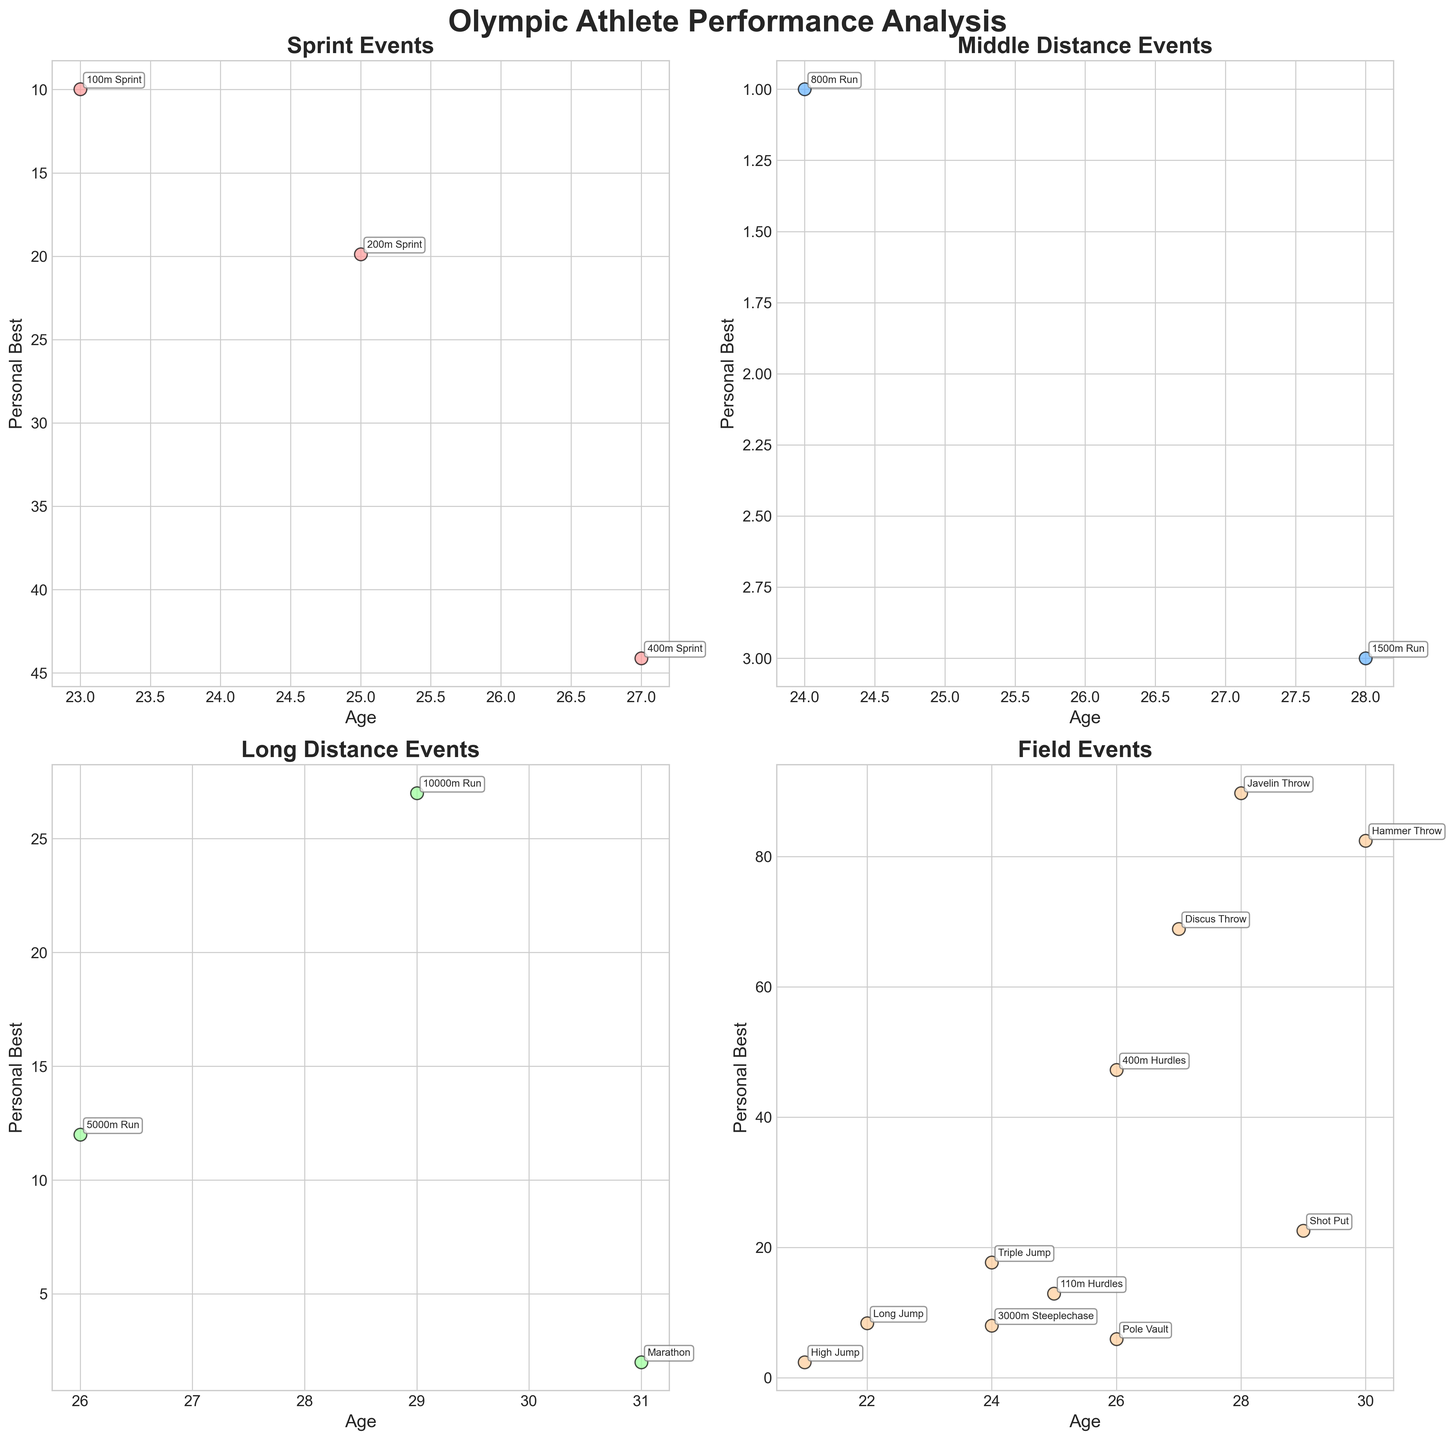How many subplots are there in the figure? There are four subplots in the figure as described in the code, each one representing a different category of athletic events (Sprint, Middle Distance, Long Distance, Field).
Answer: Four What does the x-axis represent in the subplots? The x-axis represents the age of the athletes. This is consistent across all four subplots as indicated in the code.
Answer: Age Which event has the highest average age among the sprint events? The sprint events include '100m Sprint', '200m Sprint', and '400m Sprint'. The ages are 23, 25, and 27 respectively. The average age is (23 + 25 + 27) / 3 = 25.
Answer: 400m Sprint Is there a noticeable age trend in the Field events based on the scatter plot? By observing the Field events subplot, we see a range of ages from 21 to 30. There isn’t a clear upward or downward trend visibly apparent in these age ranges.
Answer: No clear trend Among the long distance events, which event has the oldest athlete? The long distance events include the '5000m Run', '10000m Run', and 'Marathon'. The ages are 26, 29, and 31 respectively. Therefore, the Marathon has the oldest athlete at age 31.
Answer: Marathon Which subplot has events where the personal best times are inverted on the y-axis? The 'Sprint' and 'Middle Distance' subplots have the y-axis inverted for personal best times, making lower times appear higher on the graph for readability.
Answer: Sprint and Middle Distance How do personal best records compare between the '800m Run' and '1500m Run'? Looking at the 'Middle Distance' subplot, the '800m Run' personal best is 1:43.55, and the '1500m Run' is 3:29.81. Therefore, the '800m Run' has a shorter time.
Answer: Personal best for '800m Run' is shorter In the field events, which athlete has the best record in terms of distance? The events in the Field category are Long Jump, Triple Jump, Javelin Throw, Shot Put, Discus Throw, Hammer Throw, and Pole Vault. Among these, the Hammer Throw has the greatest record distance with a measure of 82.45.
Answer: Hammer Throw What can be inferred about the athletes' ages in relation to their performance in the sprint events? From the Sprint subplot, we see ages ranging from 23 to 27 and considering the inverted y-axis, younger athletes tend to have better (lower) personal best times. This suggests that younger athletes may perform better in sprint events.
Answer: Younger athletes tend to perform better in sprint events 